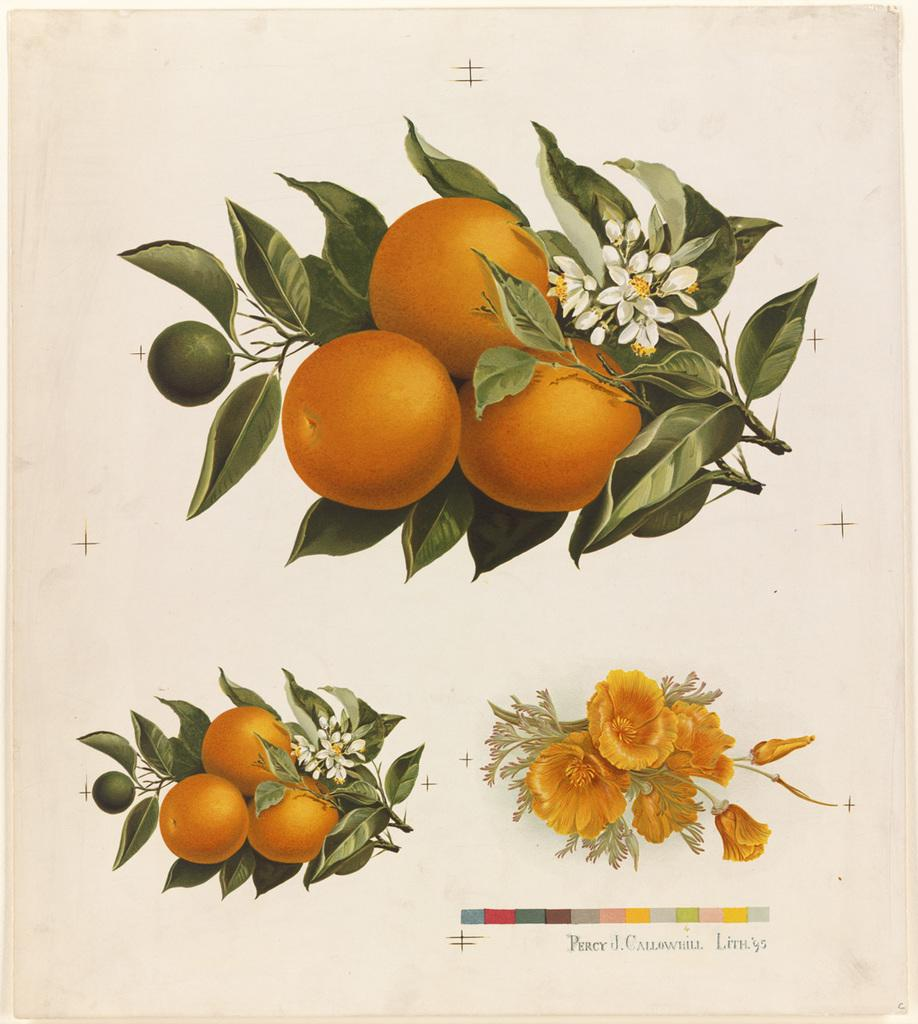What is present in the image that contains written or visual information? There is a paper in the image. What is depicted on the paper? The paper contains an image of fruits. Are there any additional elements accompanying the image of fruits? Yes, the image of fruits is accompanied by green leaves. What type of bells can be heard ringing in the image? There are no bells present in the image, and therefore no sound can be heard. What is the smell of the fruits depicted in the image? The image is a visual representation and does not convey a sense of smell. 